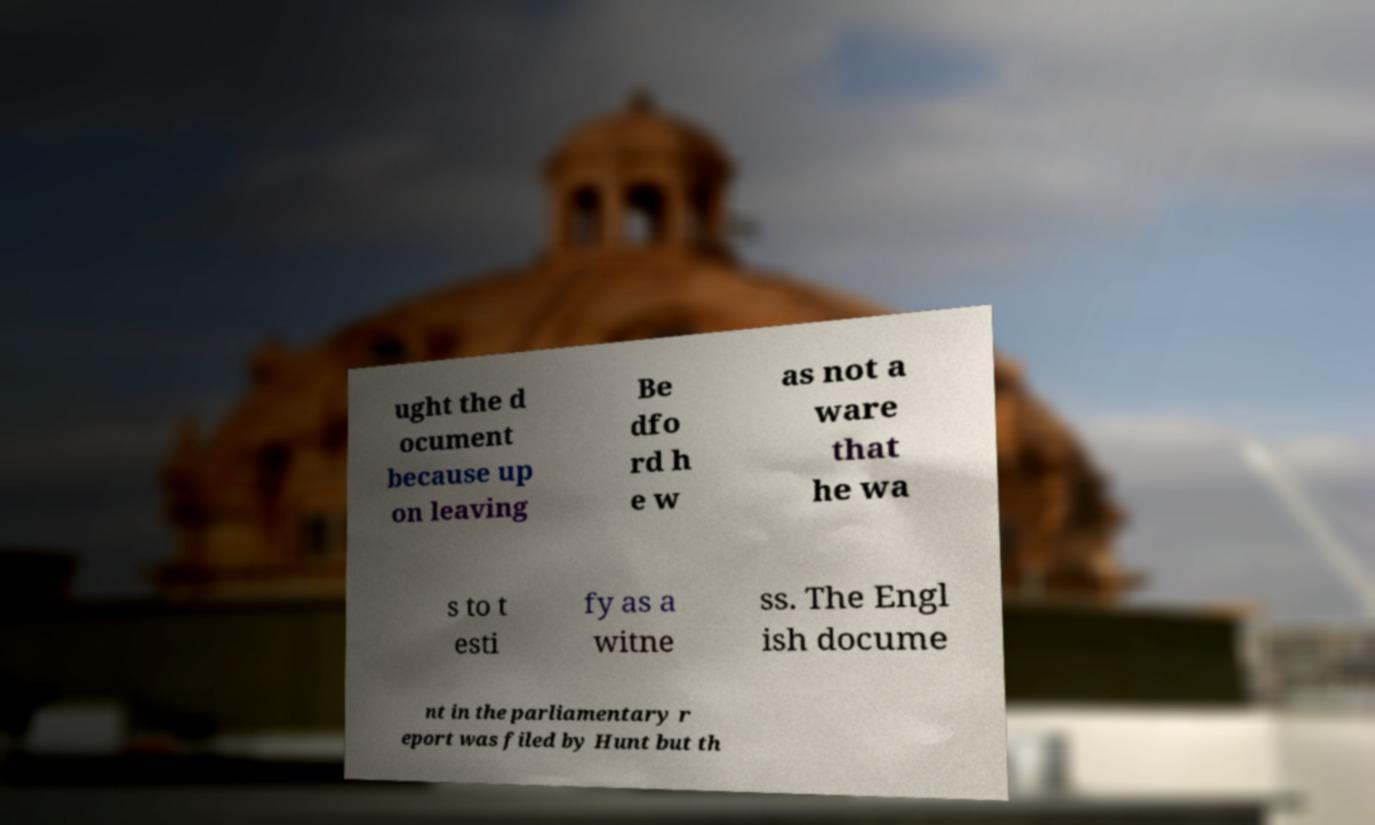What messages or text are displayed in this image? I need them in a readable, typed format. ught the d ocument because up on leaving Be dfo rd h e w as not a ware that he wa s to t esti fy as a witne ss. The Engl ish docume nt in the parliamentary r eport was filed by Hunt but th 